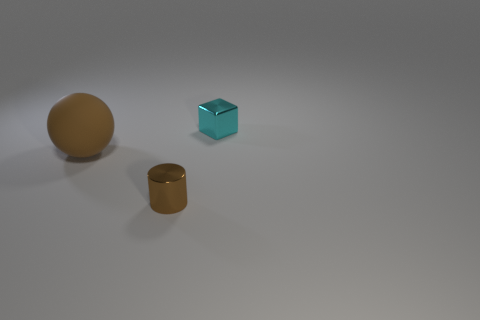Add 3 cyan cubes. How many objects exist? 6 Subtract all spheres. How many objects are left? 2 Subtract 1 brown cylinders. How many objects are left? 2 Subtract all cyan cubes. Subtract all matte objects. How many objects are left? 1 Add 1 brown shiny cylinders. How many brown shiny cylinders are left? 2 Add 2 small metallic cubes. How many small metallic cubes exist? 3 